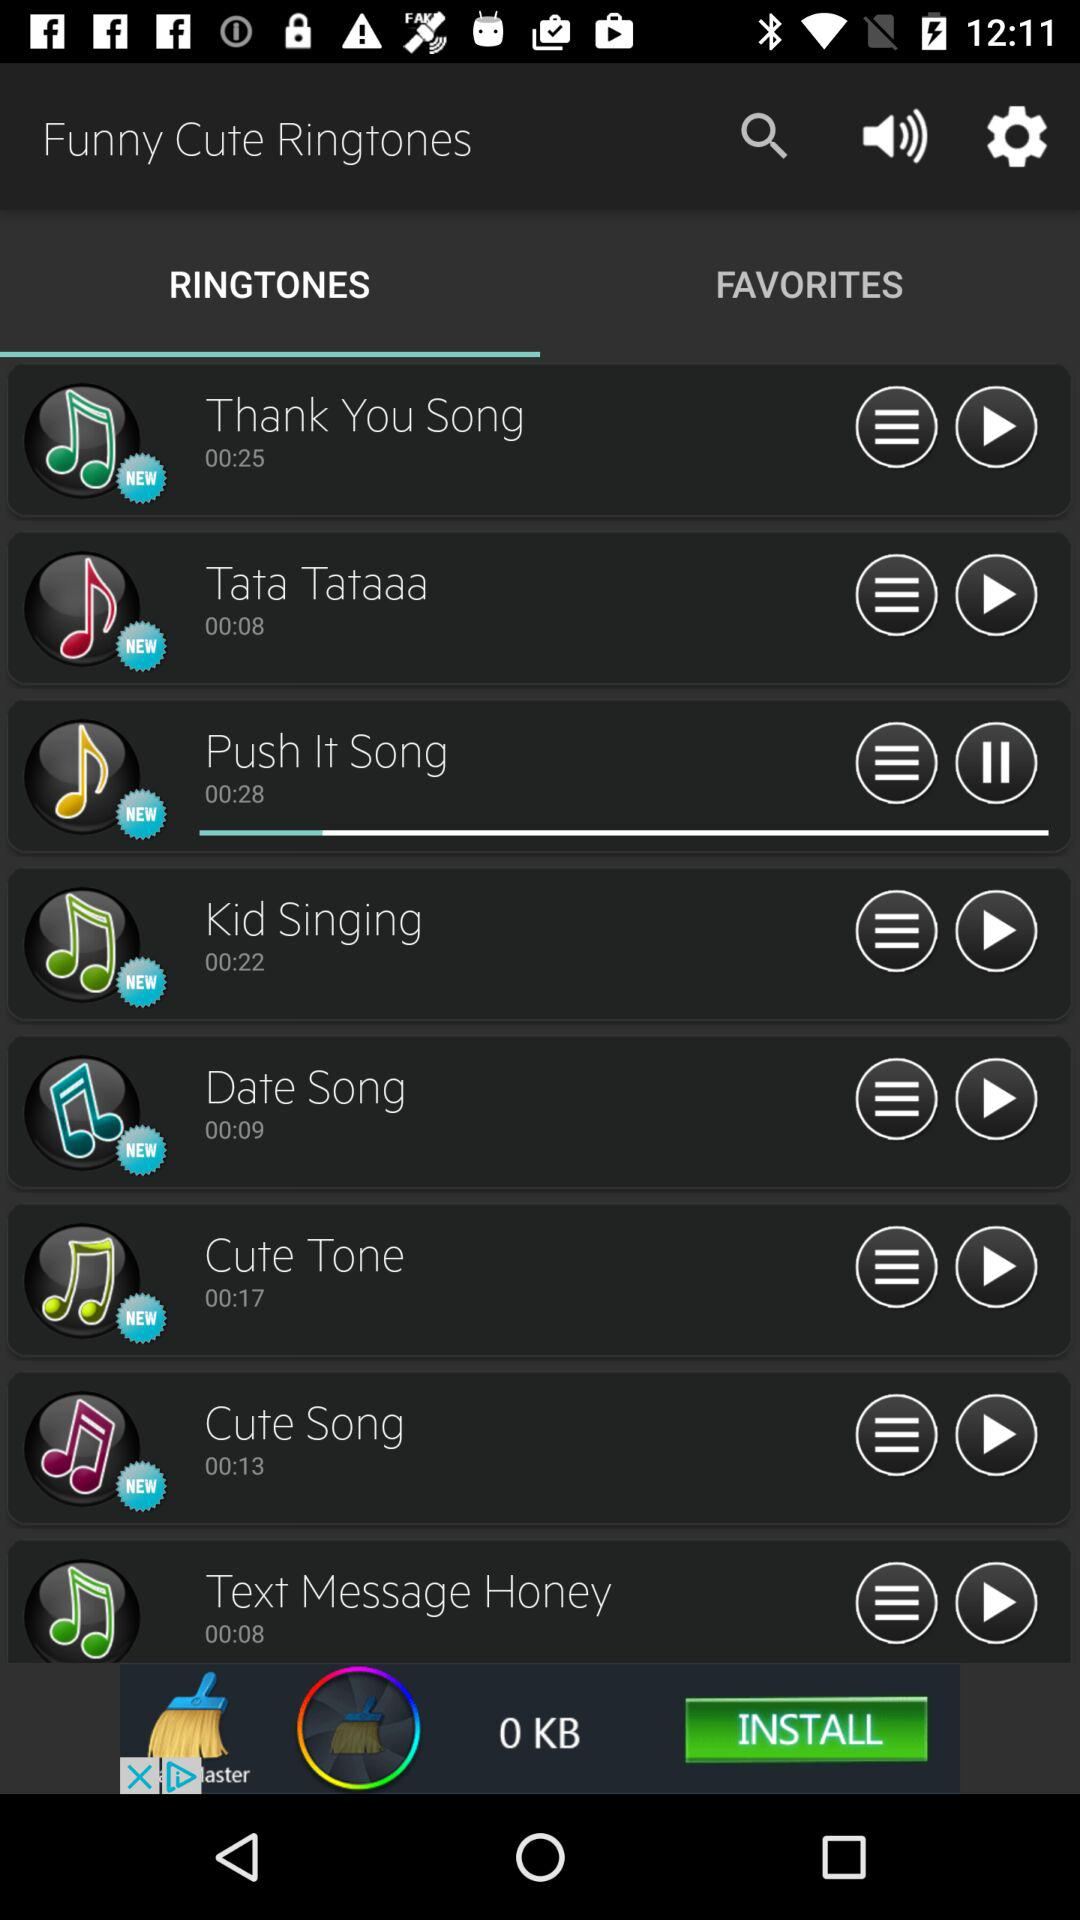Which ringtone is playing? The ringtone is "Push It Song". 